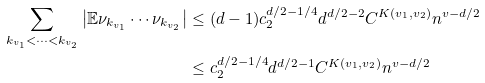Convert formula to latex. <formula><loc_0><loc_0><loc_500><loc_500>\sum _ { k _ { v _ { 1 } } < \dots < k _ { v _ { 2 } } } \left | \mathbb { E } \nu _ { k _ { v _ { 1 } } } \cdots \nu _ { k _ { v _ { 2 } } } \right | & \leq ( d - 1 ) c _ { 2 } ^ { d / 2 - 1 / 4 } d ^ { d / 2 - 2 } C ^ { K ( v _ { 1 } , v _ { 2 } ) } n ^ { v - d / 2 } \\ & \leq c _ { 2 } ^ { d / 2 - 1 / 4 } d ^ { d / 2 - 1 } C ^ { K ( v _ { 1 } , v _ { 2 } ) } n ^ { v - d / 2 }</formula> 